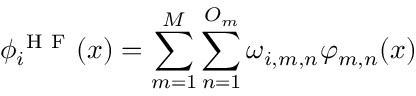Convert formula to latex. <formula><loc_0><loc_0><loc_500><loc_500>\phi _ { i } ^ { H F } ( x ) = \sum _ { m = 1 } ^ { M } \sum _ { n = 1 } ^ { O _ { m } } \omega _ { i , m , n } \varphi _ { m , n } ( x )</formula> 